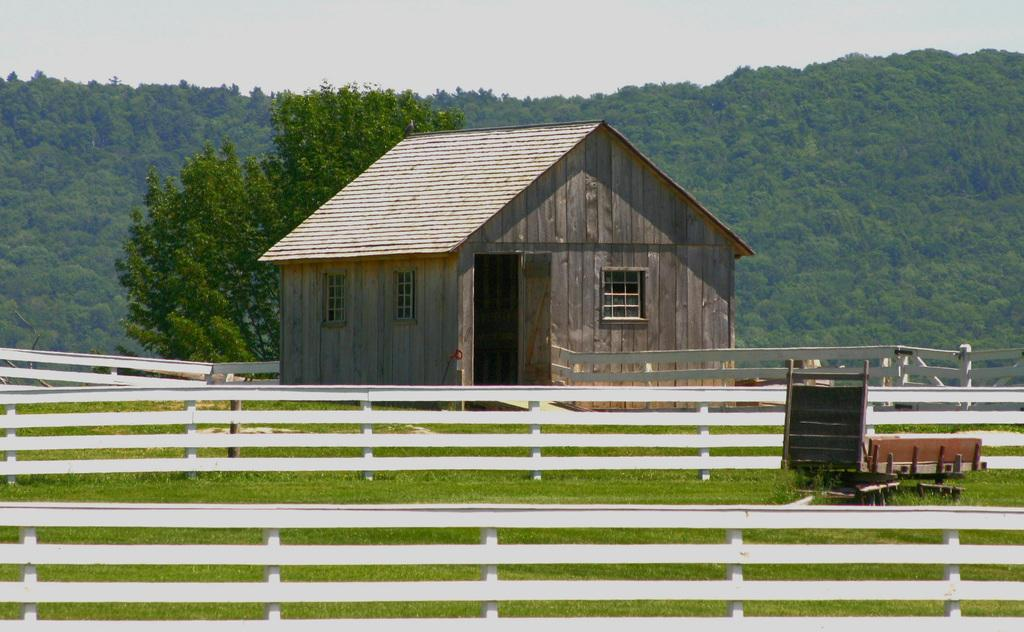What type of structure is visible in the image? There is a house with windows in the image. What is the landscape like around the house? The land is covered with grass. What type of barrier is present in the image? There is a fence in the image. What can be seen in the distance behind the house? There are trees in the background of the image. How does the carriage compare to the house in the image? There is no carriage present in the image, so it cannot be compared to the house. 